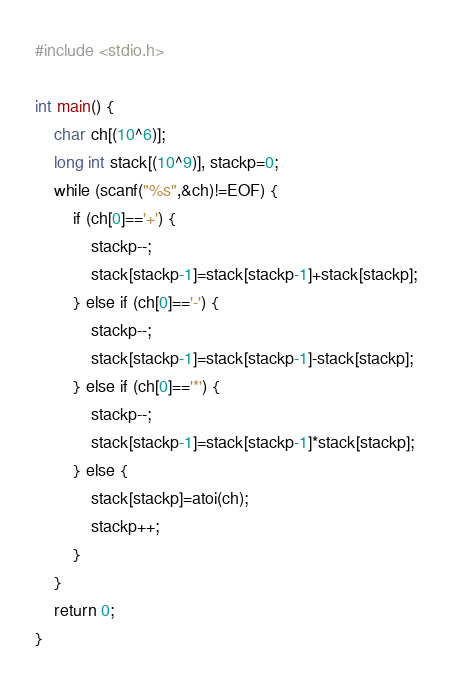<code> <loc_0><loc_0><loc_500><loc_500><_C_>#include <stdio.h>

int main() {
	char ch[(10^6)];
	long int stack[(10^9)], stackp=0;
	while (scanf("%s",&ch)!=EOF) {
		if (ch[0]=='+') {
			stackp--;
			stack[stackp-1]=stack[stackp-1]+stack[stackp];
		} else if (ch[0]=='-') {
			stackp--;
			stack[stackp-1]=stack[stackp-1]-stack[stackp];
		} else if (ch[0]=='*') {
			stackp--;
			stack[stackp-1]=stack[stackp-1]*stack[stackp];
		} else {
			stack[stackp]=atoi(ch);
			stackp++;
		}
	}
	return 0;
}</code> 